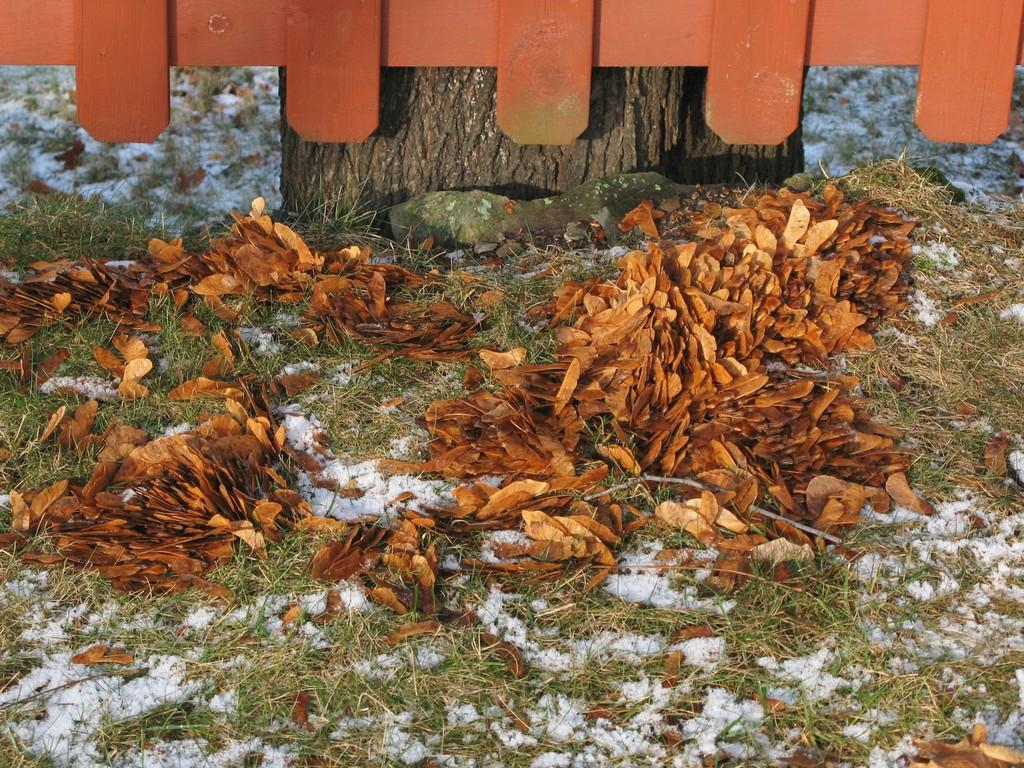What type of vegetation can be seen in the image? There are leaves and grass in the image. What structure is present in the image? There is a fence in the image. Can you describe the tree in the image? There is a tree stem in the image. What type of grape is hanging from the tree in the image? There is no grape present in the image, and the tree stem does not have any fruit. Is there a ring visible on any of the leaves in the image? There is no ring present on any of the leaves in the image. 